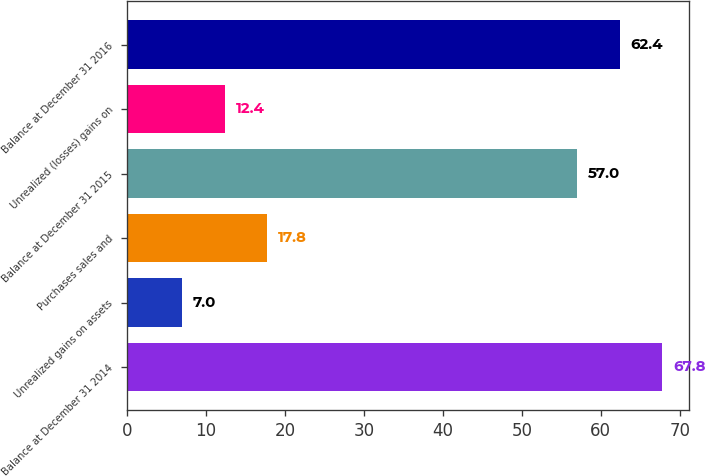<chart> <loc_0><loc_0><loc_500><loc_500><bar_chart><fcel>Balance at December 31 2014<fcel>Unrealized gains on assets<fcel>Purchases sales and<fcel>Balance at December 31 2015<fcel>Unrealized (losses) gains on<fcel>Balance at December 31 2016<nl><fcel>67.8<fcel>7<fcel>17.8<fcel>57<fcel>12.4<fcel>62.4<nl></chart> 